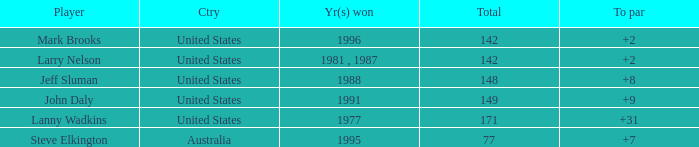Name the Total of jeff sluman? 148.0. 